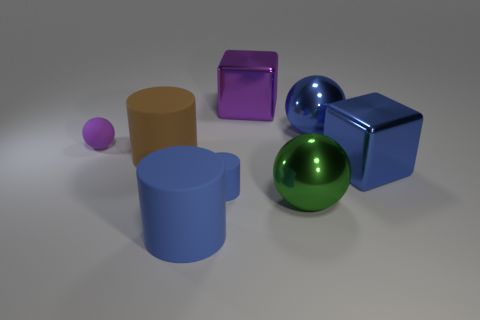Subtract all big cylinders. How many cylinders are left? 1 Subtract all blue balls. How many balls are left? 2 Subtract 2 cylinders. How many cylinders are left? 1 Add 1 green metal objects. How many objects exist? 9 Subtract all blocks. How many objects are left? 6 Subtract all blue blocks. Subtract all brown spheres. How many blocks are left? 1 Subtract all blue balls. How many blue blocks are left? 1 Subtract all large cylinders. Subtract all blue metallic spheres. How many objects are left? 5 Add 3 large brown things. How many large brown things are left? 4 Add 5 tiny gray cubes. How many tiny gray cubes exist? 5 